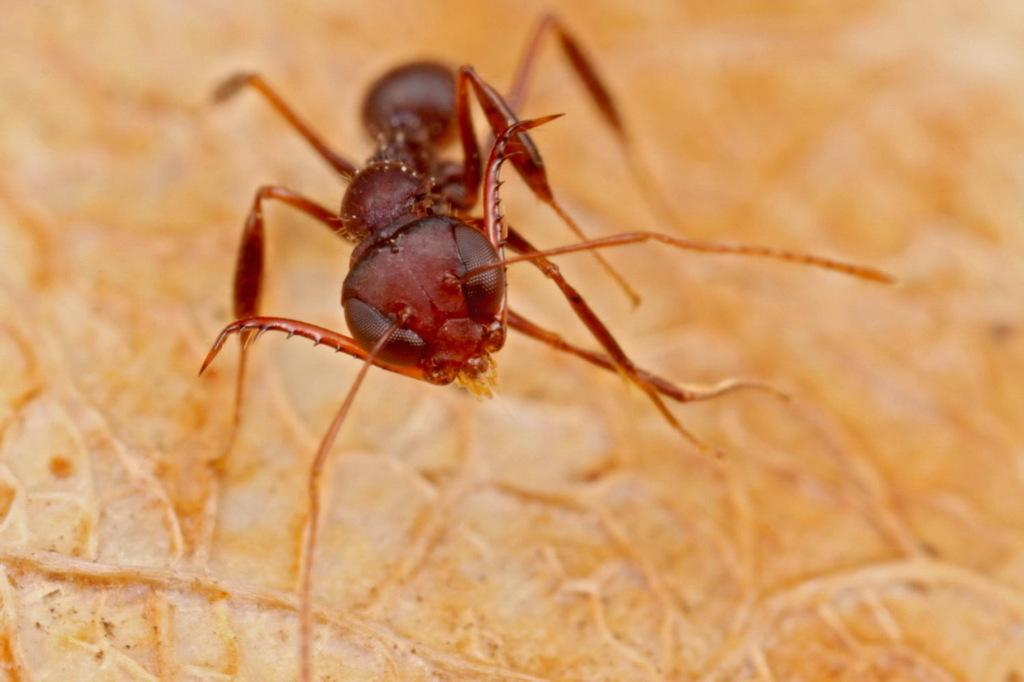What type of insect is in the image? There is a red ant in the image. What is the red ant standing on in the image? The red ant is on a yellow leaf. Is the red ant using a swing in the image? No, there is no swing present in the image. 